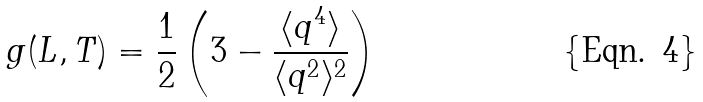Convert formula to latex. <formula><loc_0><loc_0><loc_500><loc_500>g ( L , T ) = \frac { 1 } { 2 } \left ( 3 - \frac { \langle q ^ { 4 } \rangle } { \langle q ^ { 2 } \rangle ^ { 2 } } \right )</formula> 